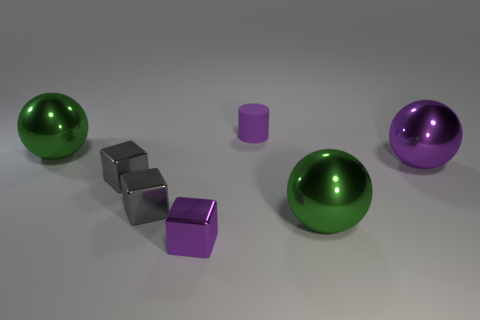Is there any other thing that is the same shape as the tiny rubber thing?
Provide a succinct answer. No. Does the large purple sphere have the same material as the purple block?
Give a very brief answer. Yes. What is the shape of the purple metallic thing that is the same size as the purple matte cylinder?
Provide a short and direct response. Cube. Are there more purple metal cubes than tiny cyan spheres?
Provide a succinct answer. Yes. What is the material of the sphere that is on the left side of the purple sphere and on the right side of the tiny cylinder?
Your response must be concise. Metal. What number of other things are made of the same material as the big purple thing?
Keep it short and to the point. 5. What number of big objects have the same color as the cylinder?
Offer a terse response. 1. There is a purple thing that is behind the green metallic thing that is on the left side of the big green shiny thing that is right of the cylinder; how big is it?
Give a very brief answer. Small. What number of metal things are tiny purple objects or large purple balls?
Offer a very short reply. 2. There is a large purple object; is its shape the same as the big shiny object on the left side of the tiny matte thing?
Your response must be concise. Yes. 